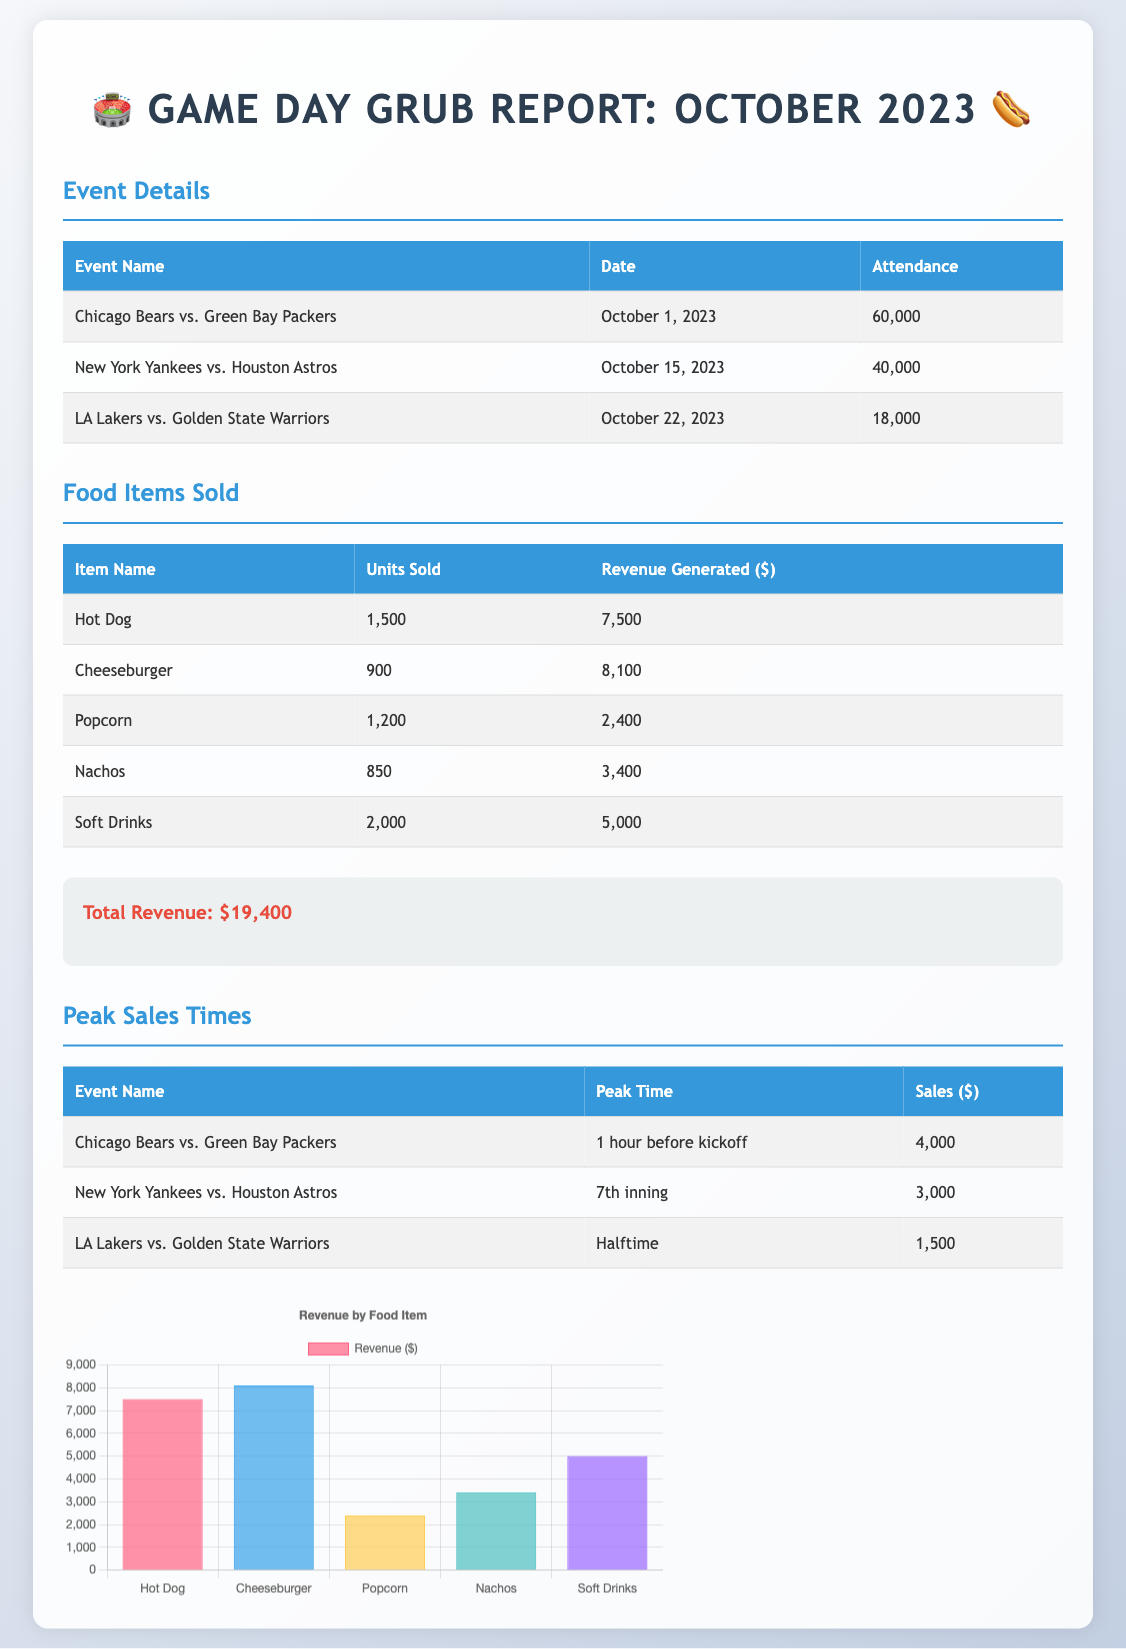What is the total revenue? The total revenue is stated in the summary section of the document.
Answer: $19,400 Which event had the highest attendance? The attendance is listed for each event in the details section, and the Chicago Bears vs. Green Bay Packers had the highest attendance of 60,000.
Answer: 60,000 How many Hot Dogs were sold? The units sold for each food item are listed in the food items sold section, where Hot Dogs sold 1,500 units.
Answer: 1,500 What was the peak sales time for the New York Yankees game? The peak sales times are provided in the peak sales table, indicating it was during the 7th inning for this game.
Answer: 7th inning Which food item generated the most revenue? The revenue generated is shown in the food items table, and the Cheeseburger generated the most revenue of $8,100.
Answer: Cheeseburger What was the revenue during halftime of the LA Lakers game? The sales amount at halftime is detailed in the peak sales times section, where it shows $1,500 in revenue.
Answer: $1,500 How many units of Soft Drinks were sold? The food items sold section lists the units sold for Soft Drinks, which totaled 2,000.
Answer: 2,000 Which event had sales of $4,000 at peak time? The peak sales table details the sales for each event, and it was for the Chicago Bears vs. Green Bay Packers.
Answer: Chicago Bears vs. Green Bay Packers What was the total attendance across all events? The total attendance is the sum of the individual attendances listed for each event, totaling 118,000.
Answer: 118,000 